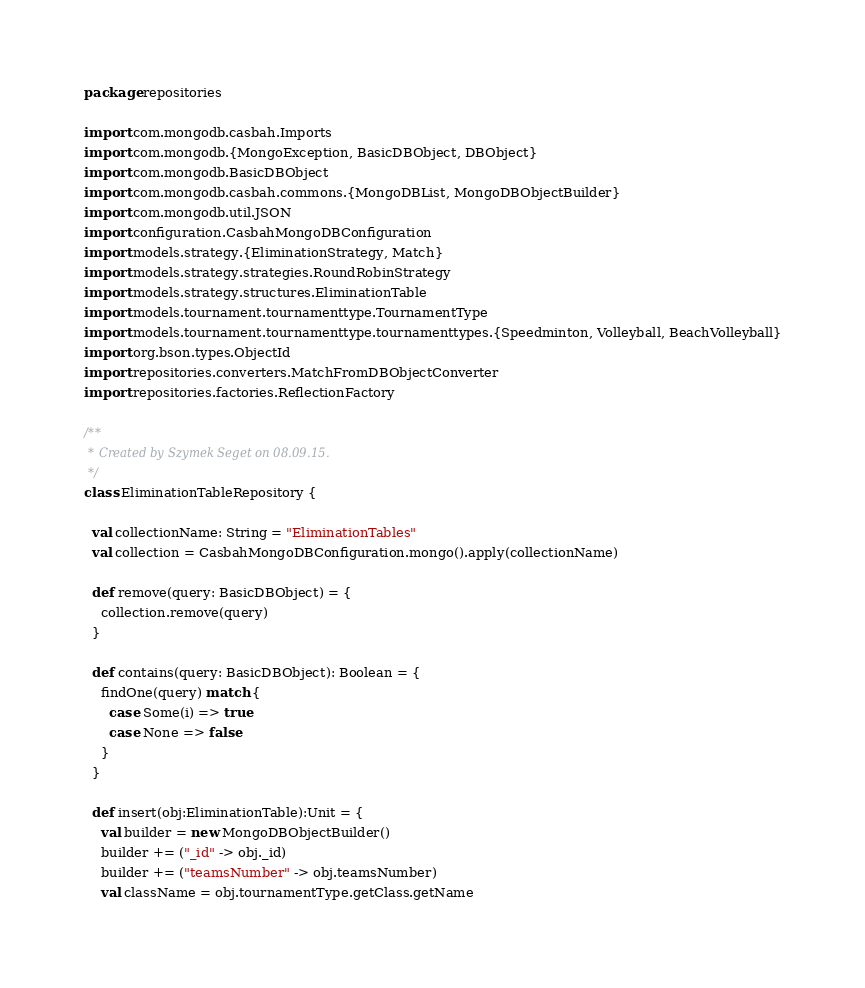<code> <loc_0><loc_0><loc_500><loc_500><_Scala_>package repositories

import com.mongodb.casbah.Imports
import com.mongodb.{MongoException, BasicDBObject, DBObject}
import com.mongodb.BasicDBObject
import com.mongodb.casbah.commons.{MongoDBList, MongoDBObjectBuilder}
import com.mongodb.util.JSON
import configuration.CasbahMongoDBConfiguration
import models.strategy.{EliminationStrategy, Match}
import models.strategy.strategies.RoundRobinStrategy
import models.strategy.structures.EliminationTable
import models.tournament.tournamenttype.TournamentType
import models.tournament.tournamenttype.tournamenttypes.{Speedminton, Volleyball, BeachVolleyball}
import org.bson.types.ObjectId
import repositories.converters.MatchFromDBObjectConverter
import repositories.factories.ReflectionFactory

/**
 * Created by Szymek Seget on 08.09.15.
 */
class EliminationTableRepository {

  val collectionName: String = "EliminationTables"
  val collection = CasbahMongoDBConfiguration.mongo().apply(collectionName)

  def remove(query: BasicDBObject) = {
    collection.remove(query)
  }

  def contains(query: BasicDBObject): Boolean = {
    findOne(query) match {
      case Some(i) => true
      case None => false
    }
  }

  def insert(obj:EliminationTable):Unit = {
    val builder = new MongoDBObjectBuilder()
    builder += ("_id" -> obj._id)
    builder += ("teamsNumber" -> obj.teamsNumber)
    val className = obj.tournamentType.getClass.getName</code> 